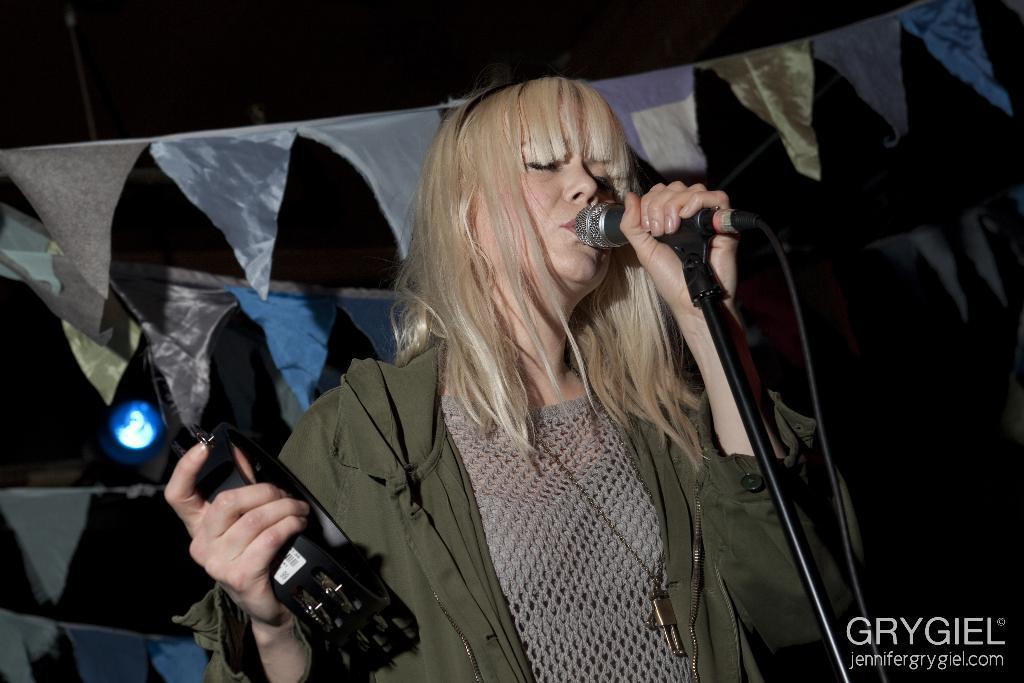Who is the main subject in the image? There is a lady in the image. What is the lady wearing? The lady is wearing a green jacket. What is the lady doing in the image? The lady is singing a song. What is the lady holding in her hand? She is holding a microphone in her hand. What else is the lady holding in the image? She is holding a musical instrument in her right hand. Reasoning: Let' Let's think step by step in order to produce the conversation. We start by identifying the main subject in the image, which is the lady. Then, we describe her appearance by mentioning the color of her jacket. Next, we focus on her actions, noting that she is singing a song. We then describe the objects she is holding, which are a microphone and a musical instrument. Each question is designed to elicit a specific detail about the image that is known from the provided facts. Absurd Question/Answer: How many trucks can be seen in the image? There are no trucks present in the image. What is the lady's hope for the future while singing in the image? The image does not provide information about the lady's hopes for the future. 